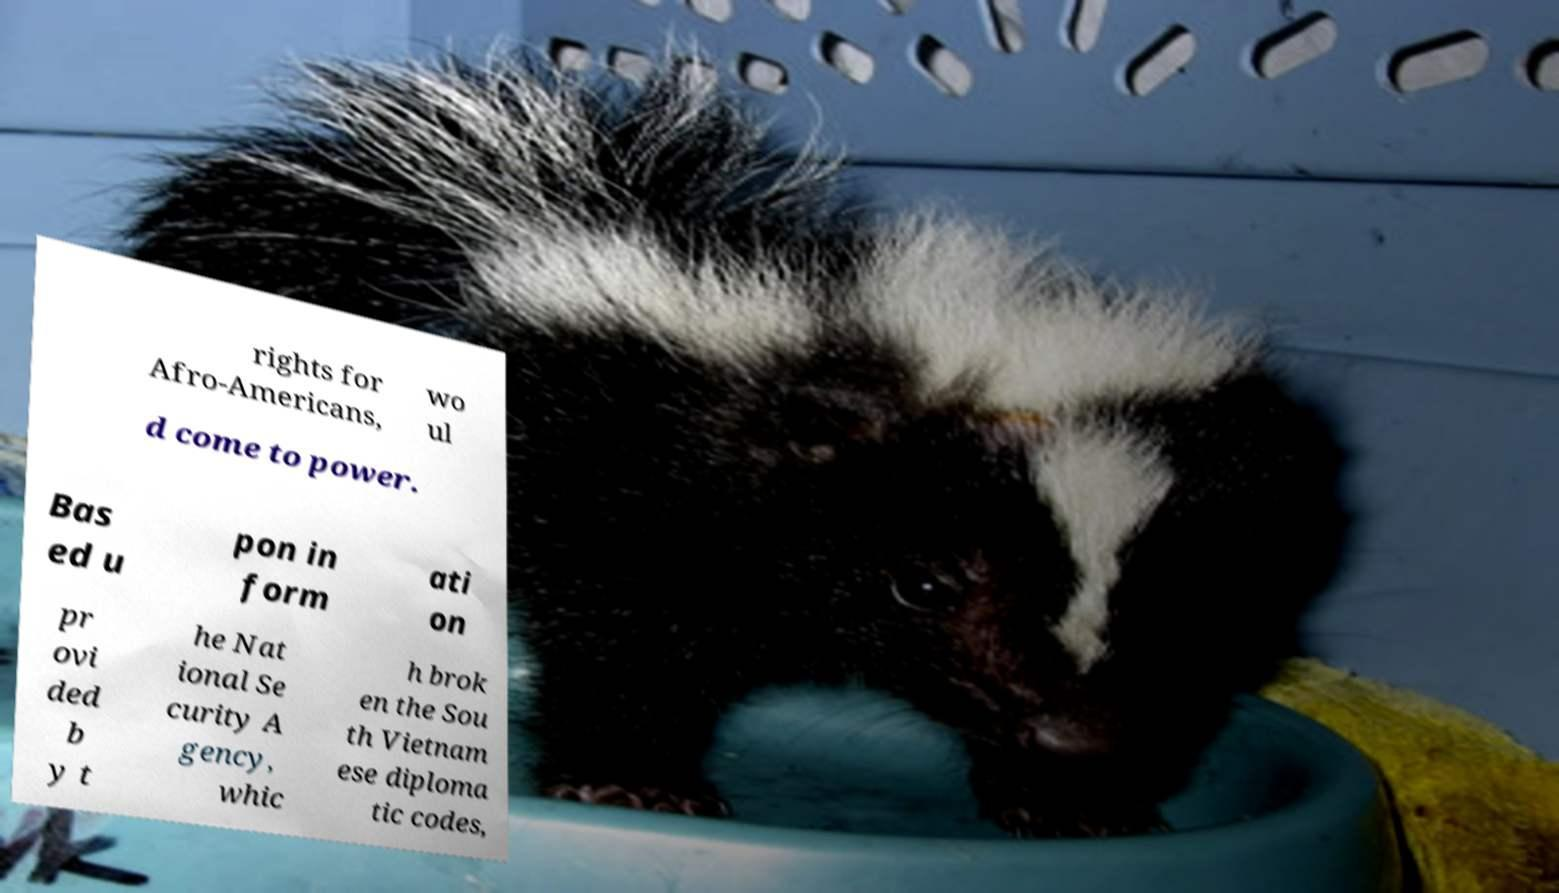What messages or text are displayed in this image? I need them in a readable, typed format. rights for Afro-Americans, wo ul d come to power. Bas ed u pon in form ati on pr ovi ded b y t he Nat ional Se curity A gency, whic h brok en the Sou th Vietnam ese diploma tic codes, 